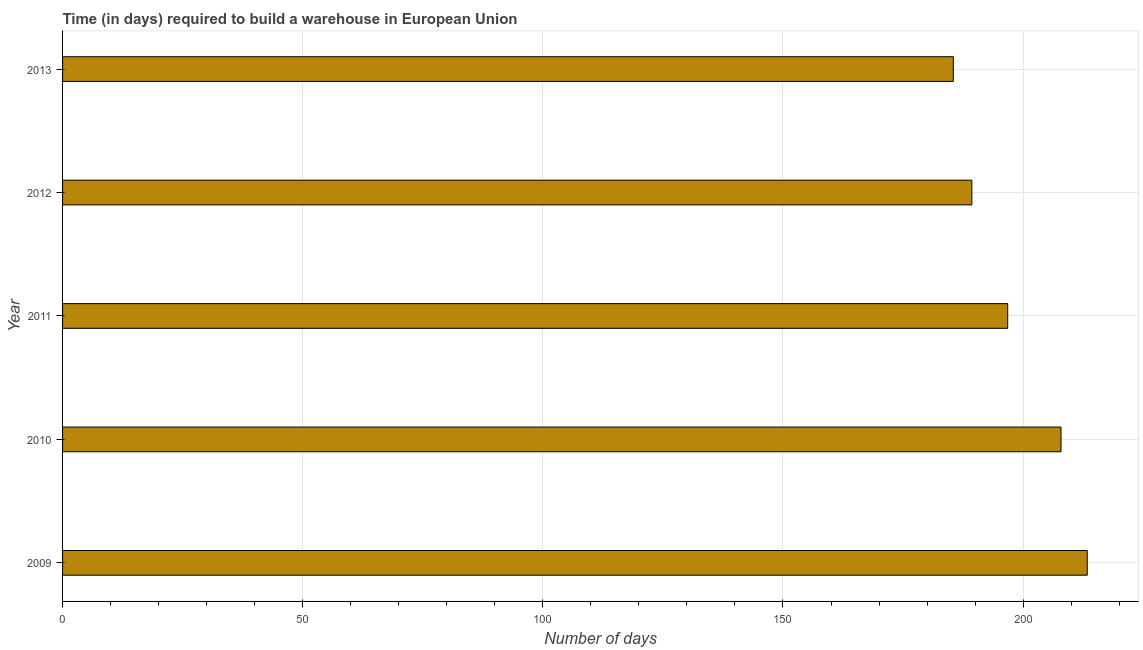Does the graph contain grids?
Provide a short and direct response. Yes. What is the title of the graph?
Make the answer very short. Time (in days) required to build a warehouse in European Union. What is the label or title of the X-axis?
Your answer should be compact. Number of days. What is the time required to build a warehouse in 2011?
Give a very brief answer. 196.79. Across all years, what is the maximum time required to build a warehouse?
Give a very brief answer. 213.35. Across all years, what is the minimum time required to build a warehouse?
Give a very brief answer. 185.46. What is the sum of the time required to build a warehouse?
Offer a terse response. 992.81. What is the difference between the time required to build a warehouse in 2010 and 2011?
Offer a terse response. 11.1. What is the average time required to build a warehouse per year?
Your answer should be compact. 198.56. What is the median time required to build a warehouse?
Offer a terse response. 196.79. What is the ratio of the time required to build a warehouse in 2009 to that in 2013?
Your answer should be very brief. 1.15. What is the difference between the highest and the second highest time required to build a warehouse?
Give a very brief answer. 5.46. Is the sum of the time required to build a warehouse in 2009 and 2013 greater than the maximum time required to build a warehouse across all years?
Ensure brevity in your answer.  Yes. What is the difference between the highest and the lowest time required to build a warehouse?
Provide a succinct answer. 27.89. In how many years, is the time required to build a warehouse greater than the average time required to build a warehouse taken over all years?
Your response must be concise. 2. How many bars are there?
Offer a very short reply. 5. Are all the bars in the graph horizontal?
Keep it short and to the point. Yes. What is the Number of days in 2009?
Keep it short and to the point. 213.35. What is the Number of days in 2010?
Your answer should be compact. 207.89. What is the Number of days in 2011?
Your response must be concise. 196.79. What is the Number of days of 2012?
Ensure brevity in your answer.  189.32. What is the Number of days of 2013?
Give a very brief answer. 185.46. What is the difference between the Number of days in 2009 and 2010?
Your answer should be very brief. 5.46. What is the difference between the Number of days in 2009 and 2011?
Make the answer very short. 16.57. What is the difference between the Number of days in 2009 and 2012?
Your answer should be very brief. 24.03. What is the difference between the Number of days in 2009 and 2013?
Your answer should be very brief. 27.89. What is the difference between the Number of days in 2010 and 2011?
Provide a succinct answer. 11.1. What is the difference between the Number of days in 2010 and 2012?
Provide a short and direct response. 18.57. What is the difference between the Number of days in 2010 and 2013?
Offer a very short reply. 22.42. What is the difference between the Number of days in 2011 and 2012?
Your response must be concise. 7.46. What is the difference between the Number of days in 2011 and 2013?
Give a very brief answer. 11.32. What is the difference between the Number of days in 2012 and 2013?
Your answer should be compact. 3.86. What is the ratio of the Number of days in 2009 to that in 2011?
Make the answer very short. 1.08. What is the ratio of the Number of days in 2009 to that in 2012?
Provide a succinct answer. 1.13. What is the ratio of the Number of days in 2009 to that in 2013?
Your answer should be compact. 1.15. What is the ratio of the Number of days in 2010 to that in 2011?
Keep it short and to the point. 1.06. What is the ratio of the Number of days in 2010 to that in 2012?
Offer a very short reply. 1.1. What is the ratio of the Number of days in 2010 to that in 2013?
Provide a short and direct response. 1.12. What is the ratio of the Number of days in 2011 to that in 2012?
Make the answer very short. 1.04. What is the ratio of the Number of days in 2011 to that in 2013?
Ensure brevity in your answer.  1.06. 